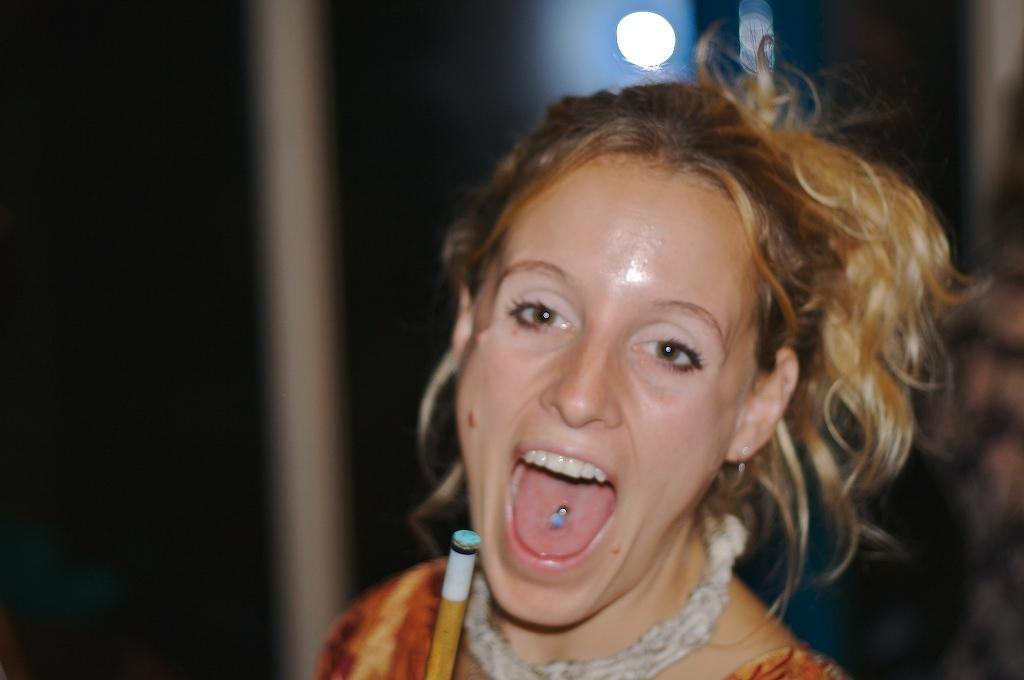What is the main subject of the image? The main subject of the image is a woman. What is the woman doing in the image? The woman is standing and smiling. Can you describe the background of the image? The background of the image is blurred. What event is the woman attending in the image? There is no information about an event in the image; it only shows a woman standing and smiling with a blurred background. 